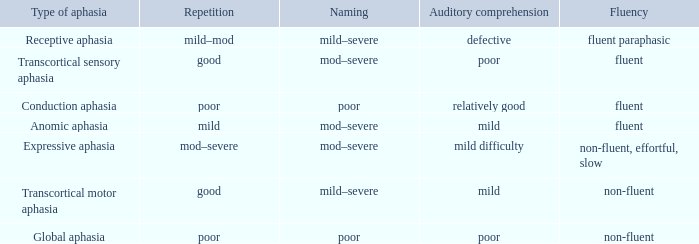Name the comprehension for non-fluent, effortful, slow Mild difficulty. 